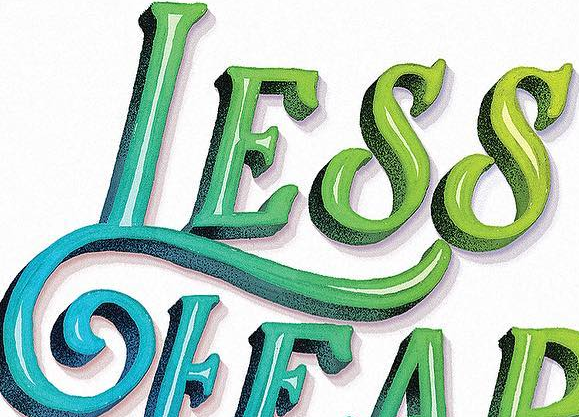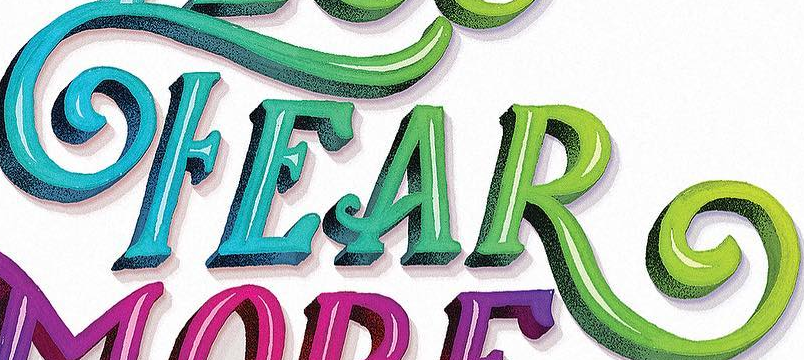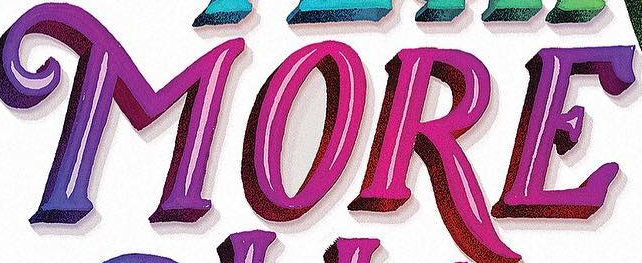Read the text from these images in sequence, separated by a semicolon. LESS; FEAR; MORE 